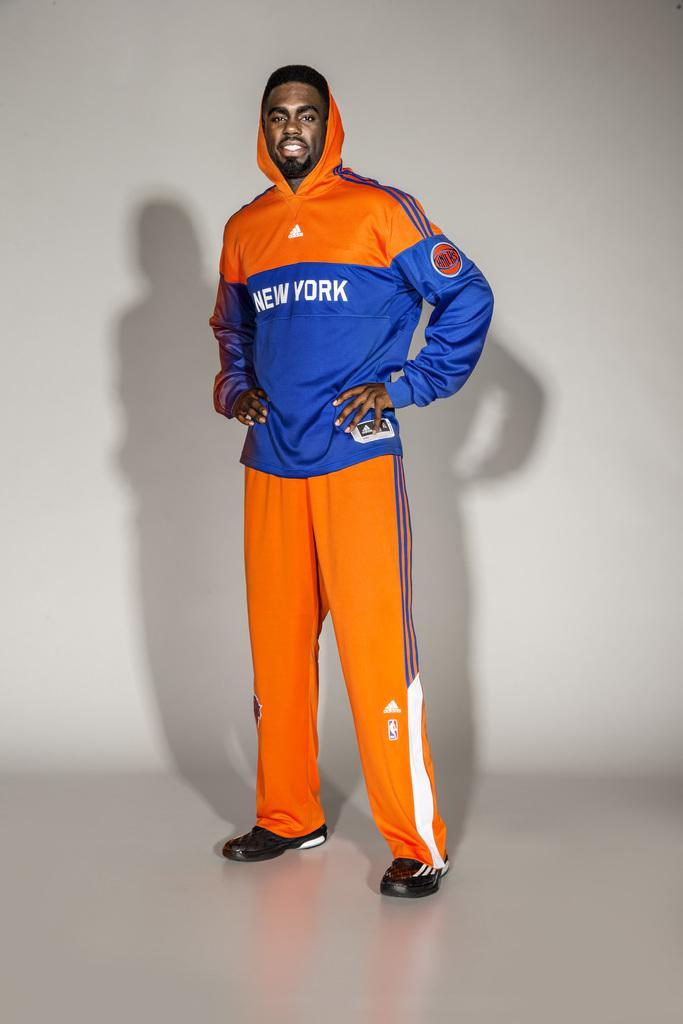<image>
Create a compact narrative representing the image presented. A man is standing with a NEW YORK KNICKS orange and blue uniform on. 